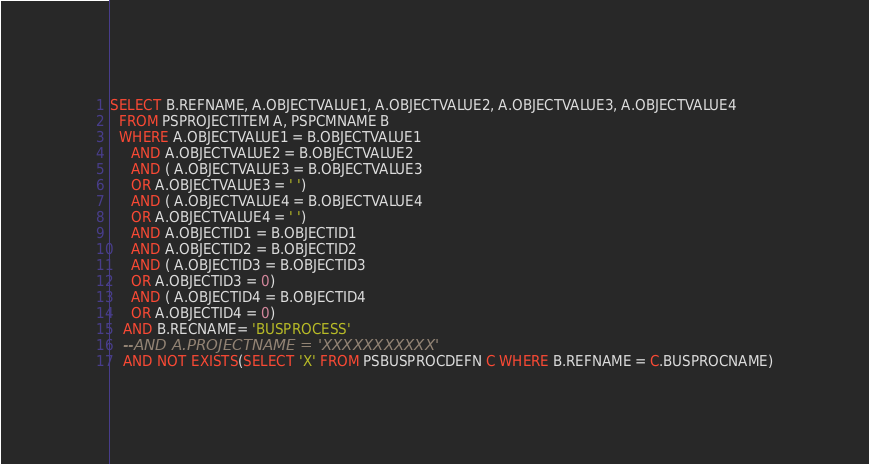<code> <loc_0><loc_0><loc_500><loc_500><_SQL_>SELECT B.REFNAME, A.OBJECTVALUE1, A.OBJECTVALUE2, A.OBJECTVALUE3, A.OBJECTVALUE4
  FROM PSPROJECTITEM A, PSPCMNAME B
  WHERE A.OBJECTVALUE1 = B.OBJECTVALUE1
     AND A.OBJECTVALUE2 = B.OBJECTVALUE2
     AND ( A.OBJECTVALUE3 = B.OBJECTVALUE3
     OR A.OBJECTVALUE3 = ' ')
     AND ( A.OBJECTVALUE4 = B.OBJECTVALUE4
     OR A.OBJECTVALUE4 = ' ')
     AND A.OBJECTID1 = B.OBJECTID1
     AND A.OBJECTID2 = B.OBJECTID2
     AND ( A.OBJECTID3 = B.OBJECTID3
     OR A.OBJECTID3 = 0)
     AND ( A.OBJECTID4 = B.OBJECTID4
     OR A.OBJECTID4 = 0)
   AND B.RECNAME= 'BUSPROCESS'
   --AND A.PROJECTNAME = 'XXXXXXXXXXX'
   AND NOT EXISTS(SELECT 'X' FROM PSBUSPROCDEFN C WHERE B.REFNAME = C.BUSPROCNAME)</code> 